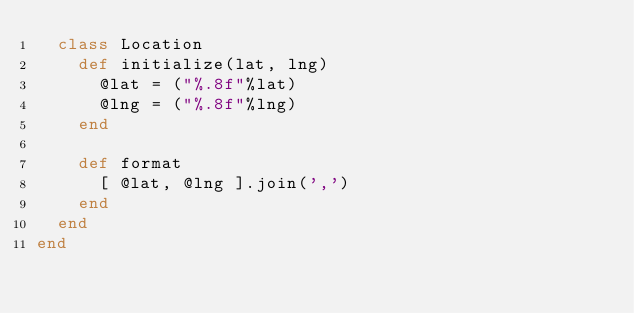Convert code to text. <code><loc_0><loc_0><loc_500><loc_500><_Ruby_>  class Location
    def initialize(lat, lng)
      @lat = ("%.8f"%lat)
      @lng = ("%.8f"%lng)
    end

    def format
      [ @lat, @lng ].join(',')
    end
  end
end
</code> 